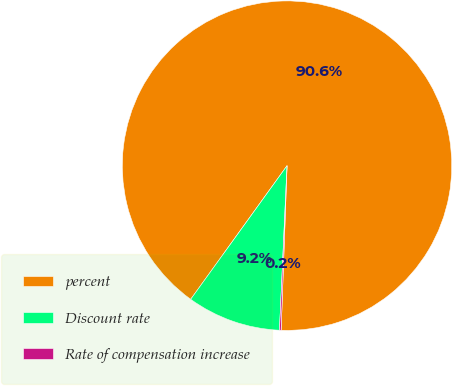<chart> <loc_0><loc_0><loc_500><loc_500><pie_chart><fcel>percent<fcel>Discount rate<fcel>Rate of compensation increase<nl><fcel>90.64%<fcel>9.21%<fcel>0.16%<nl></chart> 